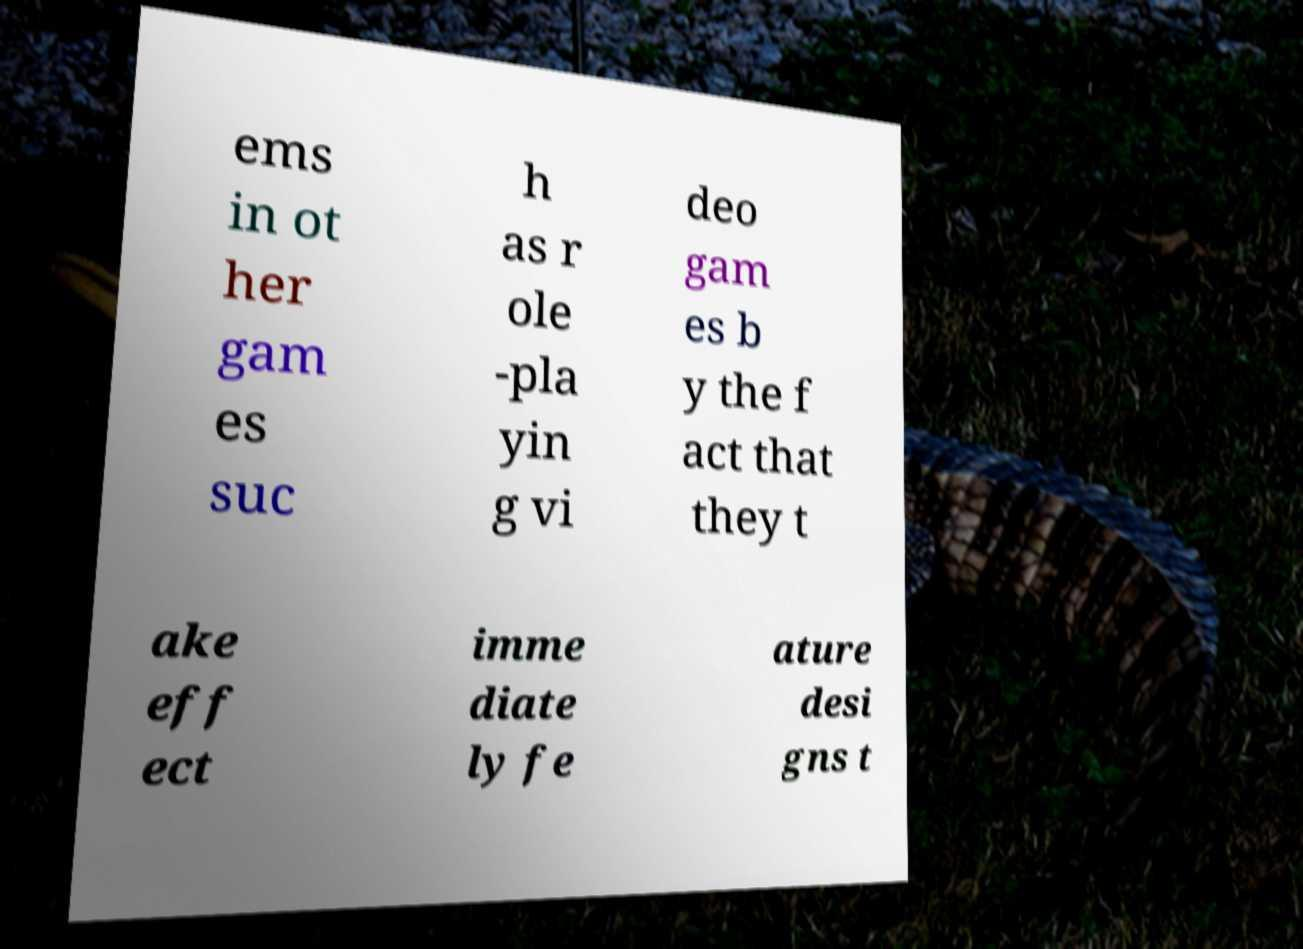Can you accurately transcribe the text from the provided image for me? ems in ot her gam es suc h as r ole -pla yin g vi deo gam es b y the f act that they t ake eff ect imme diate ly fe ature desi gns t 